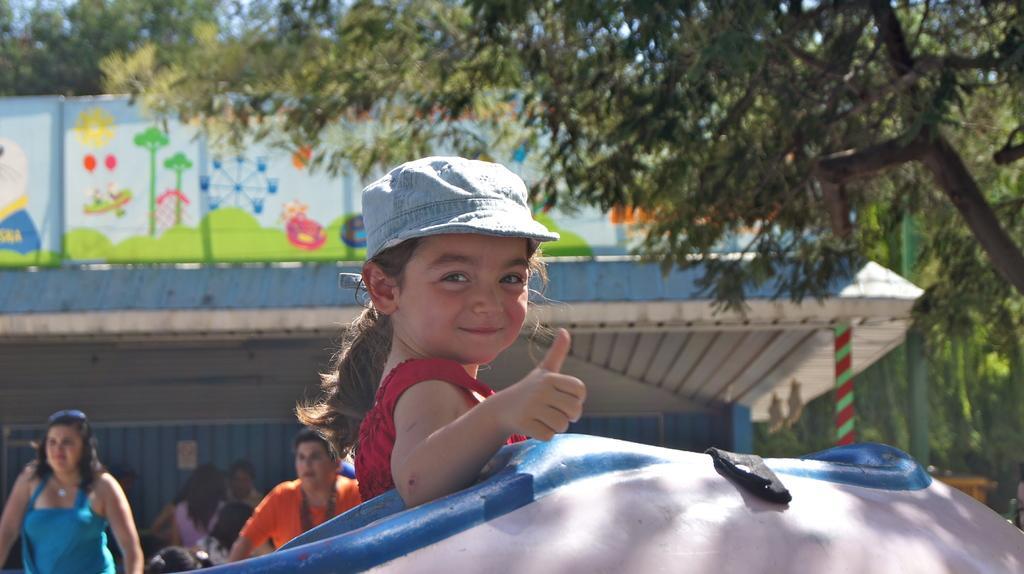Could you give a brief overview of what you see in this image? In the foreground of this image, there is a girl wearing a cap is showing thumbs up. At the bottom, there is an object. In the background, there are few people, shelter and the trees. 